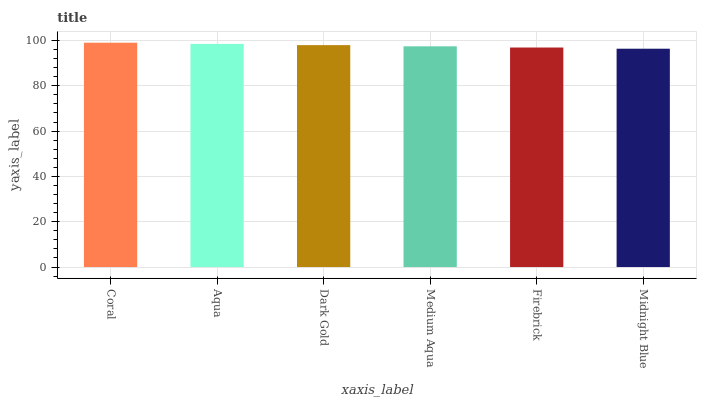Is Aqua the minimum?
Answer yes or no. No. Is Aqua the maximum?
Answer yes or no. No. Is Coral greater than Aqua?
Answer yes or no. Yes. Is Aqua less than Coral?
Answer yes or no. Yes. Is Aqua greater than Coral?
Answer yes or no. No. Is Coral less than Aqua?
Answer yes or no. No. Is Dark Gold the high median?
Answer yes or no. Yes. Is Medium Aqua the low median?
Answer yes or no. Yes. Is Aqua the high median?
Answer yes or no. No. Is Aqua the low median?
Answer yes or no. No. 